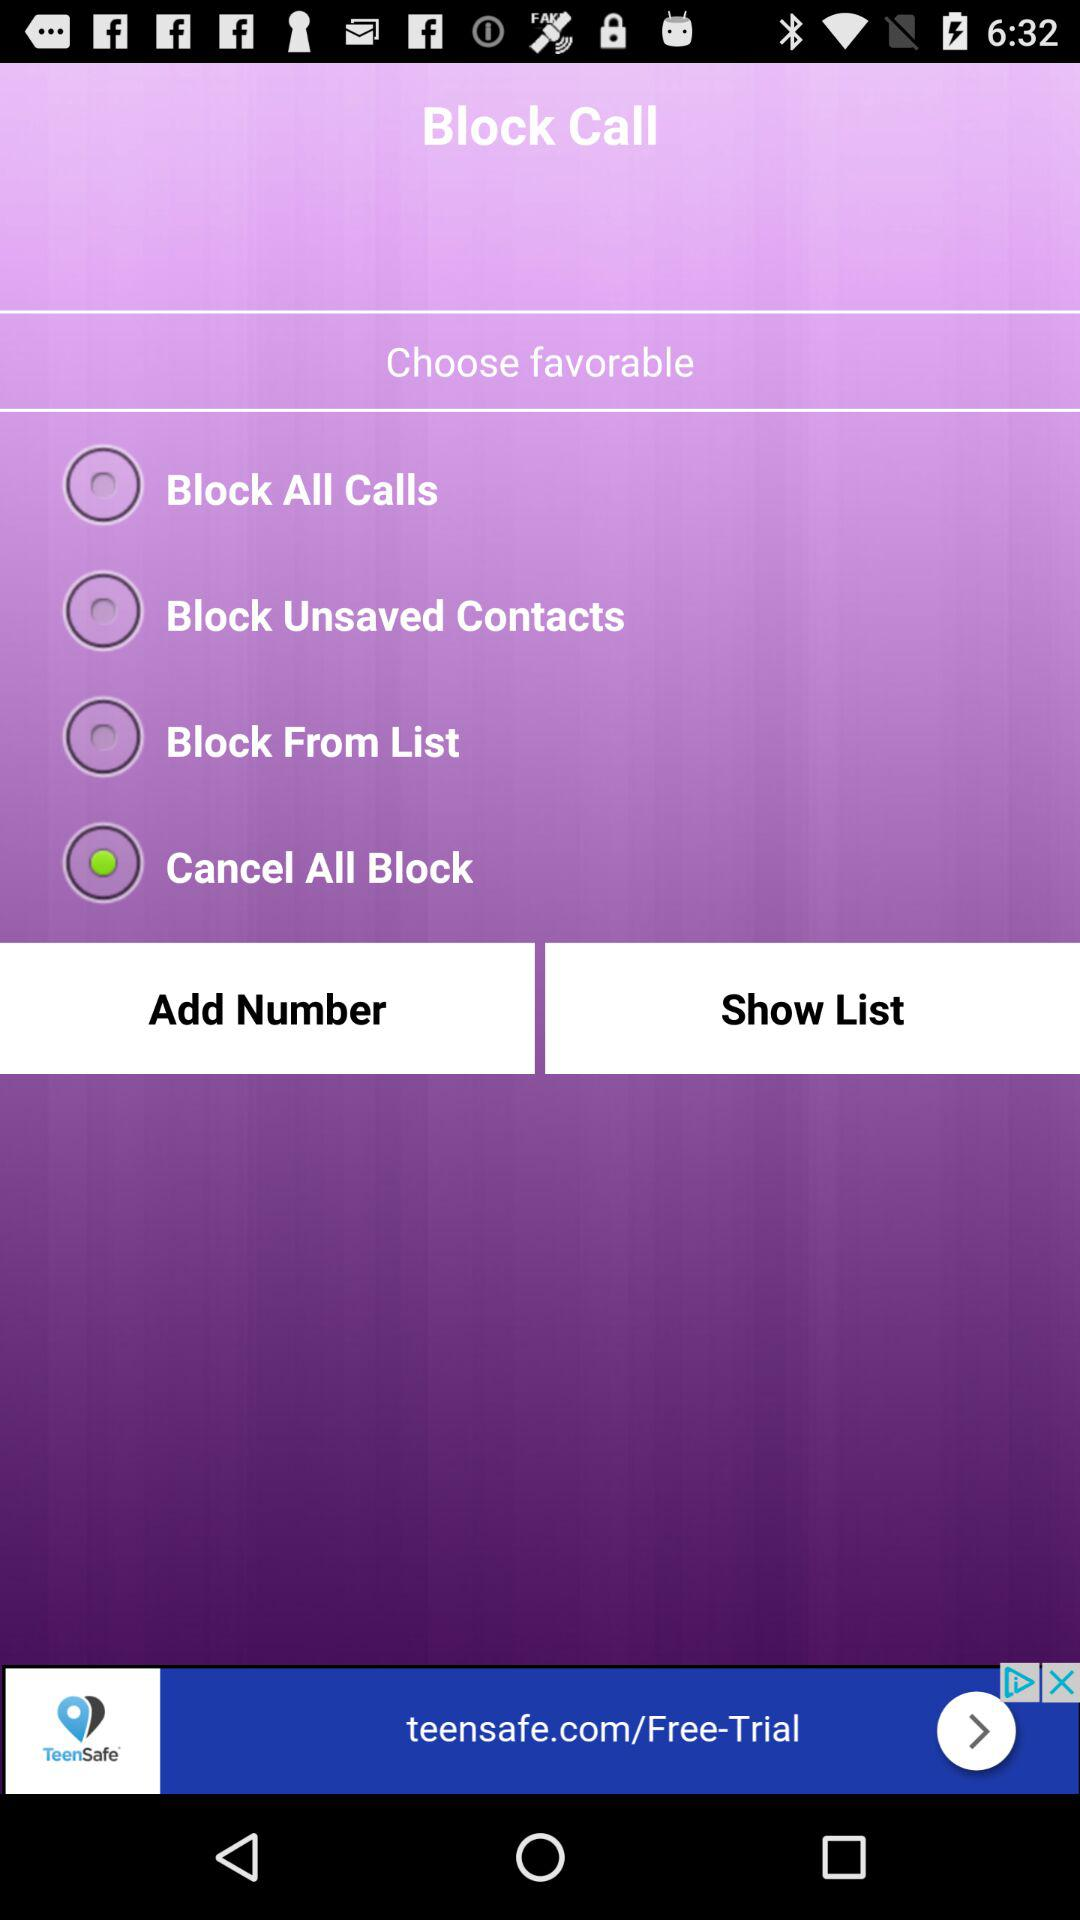Which phone numbers have been blocked?
When the provided information is insufficient, respond with <no answer>. <no answer> 